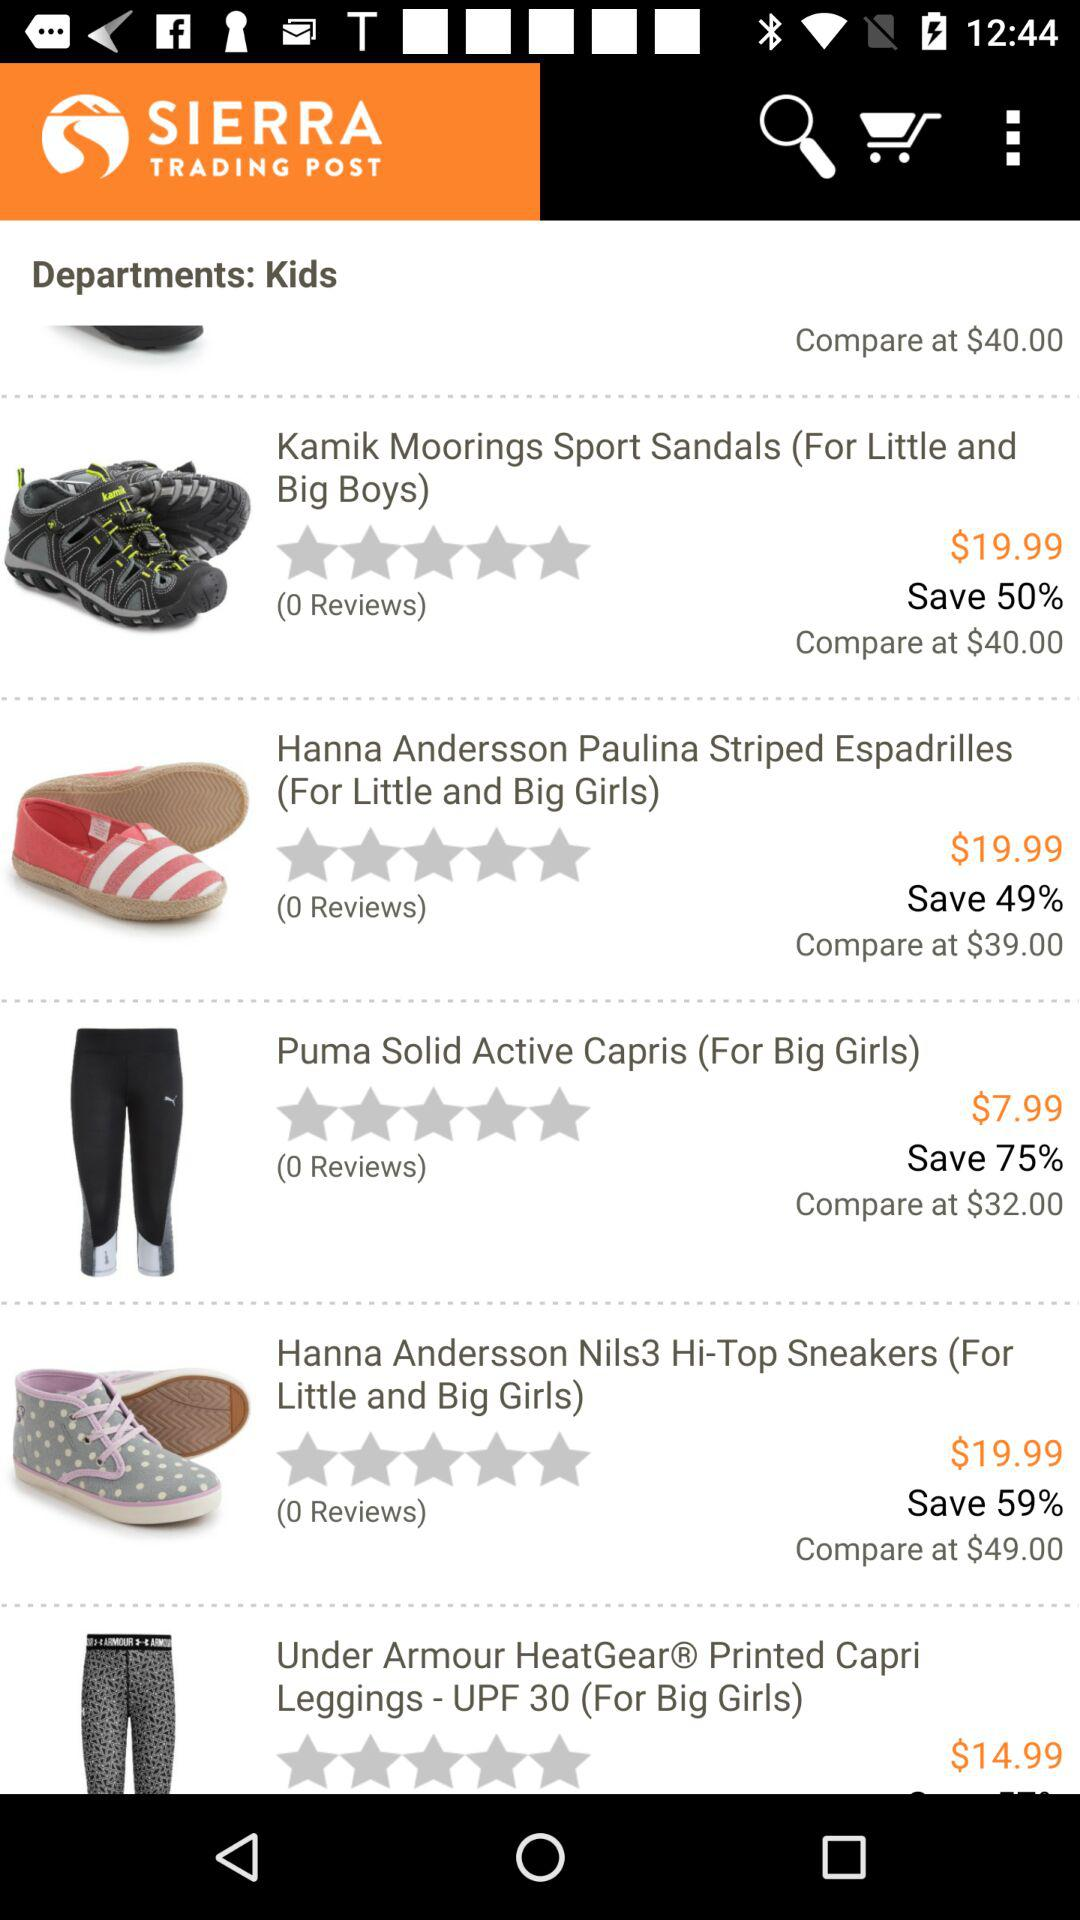What is the count of reviews for "Kamik Moorings Sport Sandals"? There are 0 reviews for "Kamik Moorings Sport Sandals". 